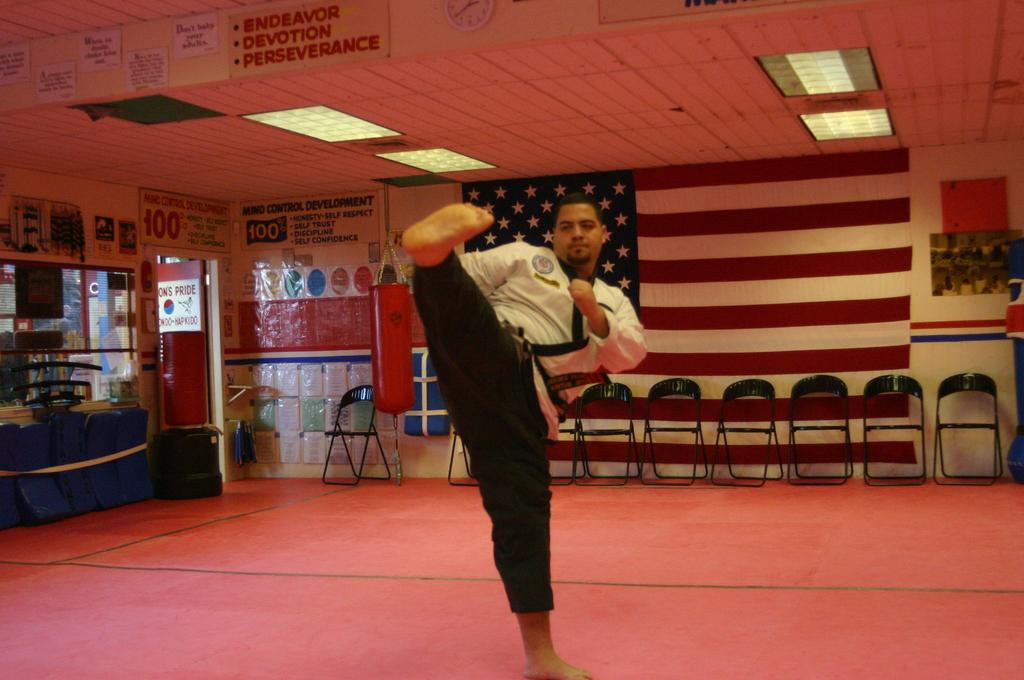<image>
Create a compact narrative representing the image presented. A man is practicing karate in an empty jojo with a sign that says Endeavor, Devotion, Perseverance. 